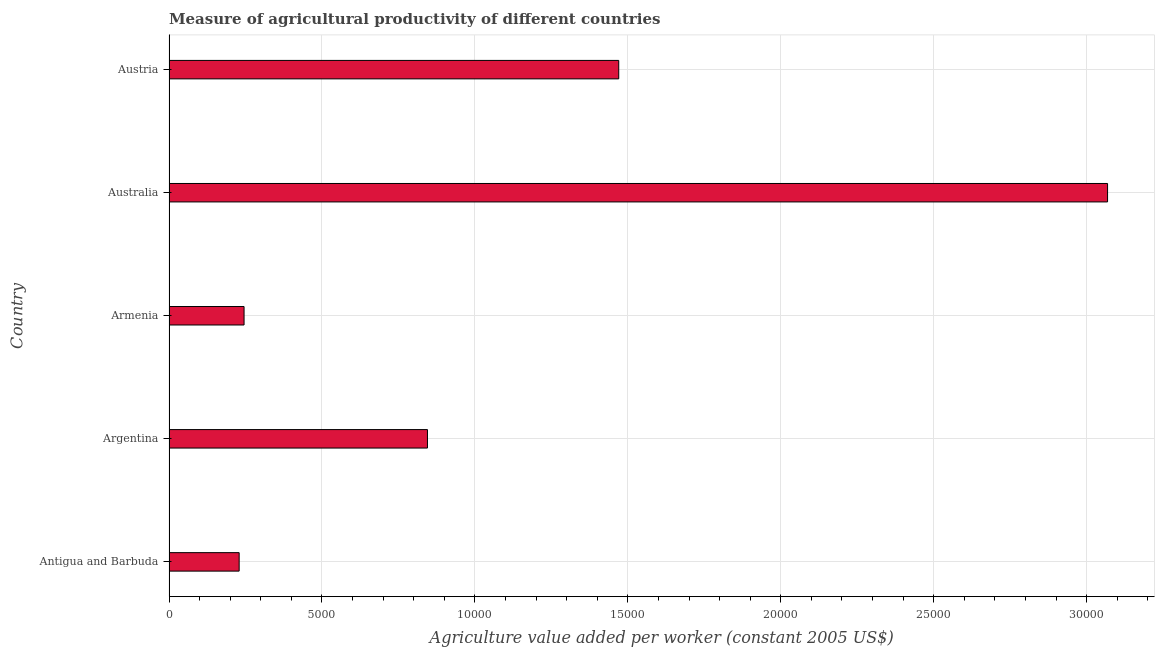Does the graph contain any zero values?
Provide a short and direct response. No. What is the title of the graph?
Keep it short and to the point. Measure of agricultural productivity of different countries. What is the label or title of the X-axis?
Keep it short and to the point. Agriculture value added per worker (constant 2005 US$). What is the agriculture value added per worker in Antigua and Barbuda?
Offer a very short reply. 2293.51. Across all countries, what is the maximum agriculture value added per worker?
Offer a terse response. 3.07e+04. Across all countries, what is the minimum agriculture value added per worker?
Offer a very short reply. 2293.51. In which country was the agriculture value added per worker minimum?
Ensure brevity in your answer.  Antigua and Barbuda. What is the sum of the agriculture value added per worker?
Your response must be concise. 5.86e+04. What is the difference between the agriculture value added per worker in Antigua and Barbuda and Armenia?
Ensure brevity in your answer.  -160.26. What is the average agriculture value added per worker per country?
Offer a terse response. 1.17e+04. What is the median agriculture value added per worker?
Give a very brief answer. 8449.84. In how many countries, is the agriculture value added per worker greater than 25000 US$?
Offer a very short reply. 1. What is the ratio of the agriculture value added per worker in Antigua and Barbuda to that in Austria?
Ensure brevity in your answer.  0.16. What is the difference between the highest and the second highest agriculture value added per worker?
Your answer should be compact. 1.60e+04. What is the difference between the highest and the lowest agriculture value added per worker?
Your response must be concise. 2.84e+04. In how many countries, is the agriculture value added per worker greater than the average agriculture value added per worker taken over all countries?
Keep it short and to the point. 2. How many bars are there?
Make the answer very short. 5. Are all the bars in the graph horizontal?
Ensure brevity in your answer.  Yes. How many countries are there in the graph?
Give a very brief answer. 5. What is the difference between two consecutive major ticks on the X-axis?
Provide a succinct answer. 5000. Are the values on the major ticks of X-axis written in scientific E-notation?
Provide a short and direct response. No. What is the Agriculture value added per worker (constant 2005 US$) in Antigua and Barbuda?
Ensure brevity in your answer.  2293.51. What is the Agriculture value added per worker (constant 2005 US$) in Argentina?
Your answer should be very brief. 8449.84. What is the Agriculture value added per worker (constant 2005 US$) of Armenia?
Keep it short and to the point. 2453.77. What is the Agriculture value added per worker (constant 2005 US$) of Australia?
Make the answer very short. 3.07e+04. What is the Agriculture value added per worker (constant 2005 US$) of Austria?
Offer a terse response. 1.47e+04. What is the difference between the Agriculture value added per worker (constant 2005 US$) in Antigua and Barbuda and Argentina?
Make the answer very short. -6156.33. What is the difference between the Agriculture value added per worker (constant 2005 US$) in Antigua and Barbuda and Armenia?
Your answer should be compact. -160.26. What is the difference between the Agriculture value added per worker (constant 2005 US$) in Antigua and Barbuda and Australia?
Offer a very short reply. -2.84e+04. What is the difference between the Agriculture value added per worker (constant 2005 US$) in Antigua and Barbuda and Austria?
Give a very brief answer. -1.24e+04. What is the difference between the Agriculture value added per worker (constant 2005 US$) in Argentina and Armenia?
Ensure brevity in your answer.  5996.07. What is the difference between the Agriculture value added per worker (constant 2005 US$) in Argentina and Australia?
Provide a succinct answer. -2.22e+04. What is the difference between the Agriculture value added per worker (constant 2005 US$) in Argentina and Austria?
Your answer should be very brief. -6253.27. What is the difference between the Agriculture value added per worker (constant 2005 US$) in Armenia and Australia?
Keep it short and to the point. -2.82e+04. What is the difference between the Agriculture value added per worker (constant 2005 US$) in Armenia and Austria?
Your answer should be compact. -1.22e+04. What is the difference between the Agriculture value added per worker (constant 2005 US$) in Australia and Austria?
Ensure brevity in your answer.  1.60e+04. What is the ratio of the Agriculture value added per worker (constant 2005 US$) in Antigua and Barbuda to that in Argentina?
Your answer should be very brief. 0.27. What is the ratio of the Agriculture value added per worker (constant 2005 US$) in Antigua and Barbuda to that in Armenia?
Your response must be concise. 0.94. What is the ratio of the Agriculture value added per worker (constant 2005 US$) in Antigua and Barbuda to that in Australia?
Your answer should be compact. 0.07. What is the ratio of the Agriculture value added per worker (constant 2005 US$) in Antigua and Barbuda to that in Austria?
Ensure brevity in your answer.  0.16. What is the ratio of the Agriculture value added per worker (constant 2005 US$) in Argentina to that in Armenia?
Provide a succinct answer. 3.44. What is the ratio of the Agriculture value added per worker (constant 2005 US$) in Argentina to that in Australia?
Offer a terse response. 0.28. What is the ratio of the Agriculture value added per worker (constant 2005 US$) in Argentina to that in Austria?
Your response must be concise. 0.57. What is the ratio of the Agriculture value added per worker (constant 2005 US$) in Armenia to that in Austria?
Make the answer very short. 0.17. What is the ratio of the Agriculture value added per worker (constant 2005 US$) in Australia to that in Austria?
Offer a terse response. 2.09. 